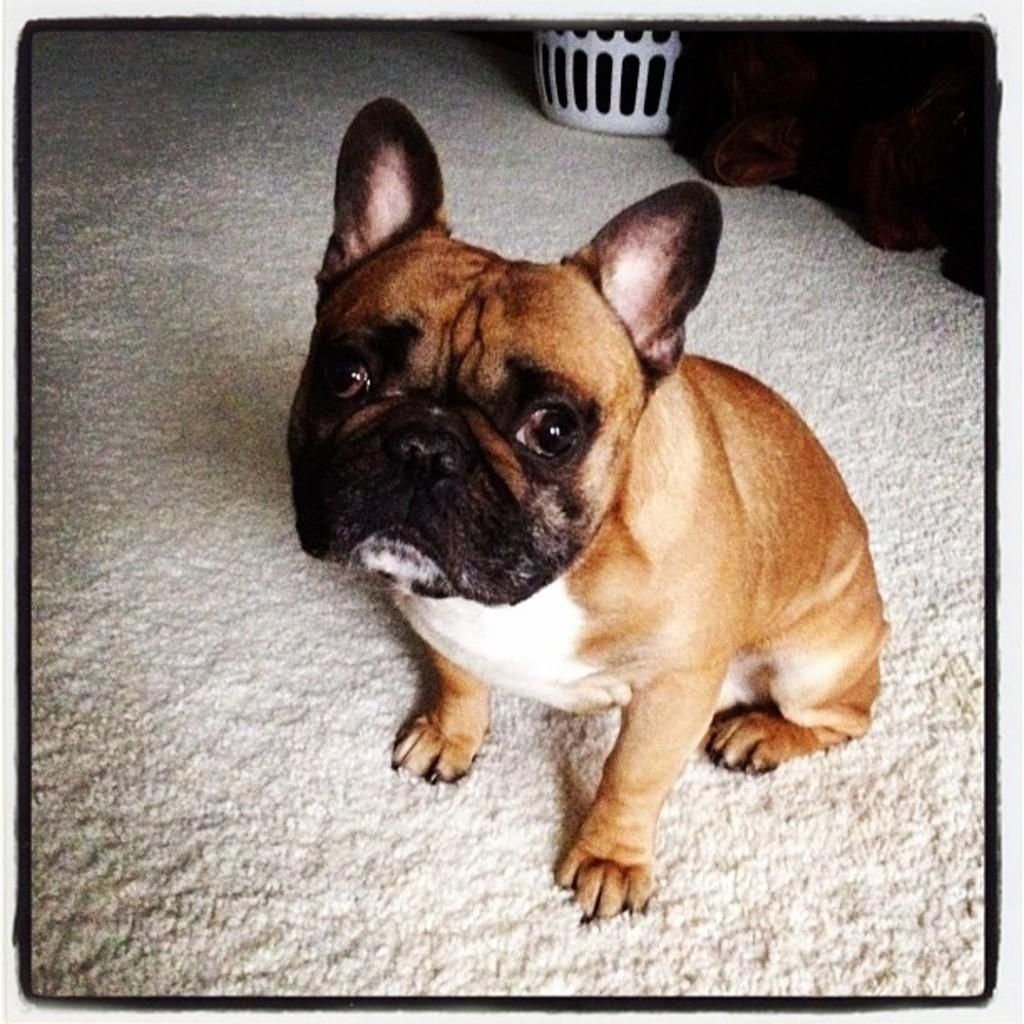What type of animal is in the image? There is a dog in the image. What colors can be seen on the dog? The dog has brown, black, and white colors. What can be seen in the background of the image? There is a white object in the background of the image. What type of industry is depicted in the image? There is no industry present in the image; it features a dog with brown, black, and white colors and a white object in the background. 